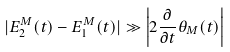<formula> <loc_0><loc_0><loc_500><loc_500>| E _ { 2 } ^ { M } ( t ) - E _ { 1 } ^ { M } ( t ) | \gg \left | 2 \frac { \partial } { \partial t } \theta _ { M } ( t ) \right |</formula> 